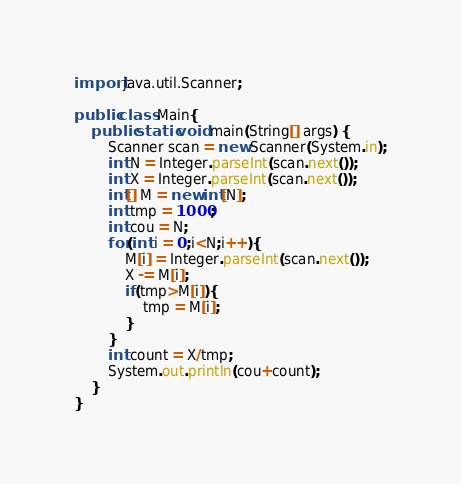Convert code to text. <code><loc_0><loc_0><loc_500><loc_500><_Java_>import java.util.Scanner;

public class Main{
    public static void main(String[] args) {
        Scanner scan = new Scanner(System.in);
        int N = Integer.parseInt(scan.next());
        int X = Integer.parseInt(scan.next());
        int[] M = new int[N];
        int tmp = 1000;
        int cou = N;
        for(int i = 0;i<N;i++){
            M[i] = Integer.parseInt(scan.next());
            X -= M[i];
            if(tmp>M[i]){
                tmp = M[i];
            }
        }
        int count = X/tmp;
        System.out.println(cou+count);
    }
}</code> 